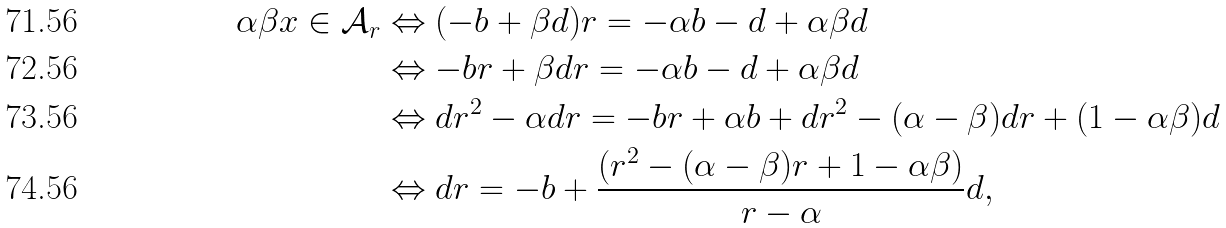Convert formula to latex. <formula><loc_0><loc_0><loc_500><loc_500>\alpha \beta x \in \mathcal { A } _ { r } & \Leftrightarrow ( - b + \beta d ) r = - \alpha b - d + \alpha \beta d \\ & \Leftrightarrow - b r + \beta d r = - \alpha b - d + \alpha \beta d \\ & \Leftrightarrow d r ^ { 2 } - \alpha d r = - b r + \alpha b + d r ^ { 2 } - ( \alpha - \beta ) d r + ( 1 - \alpha \beta ) d \\ & \Leftrightarrow d r = - b + \frac { ( r ^ { 2 } - ( \alpha - \beta ) r + 1 - \alpha \beta ) } { r - \alpha } d ,</formula> 